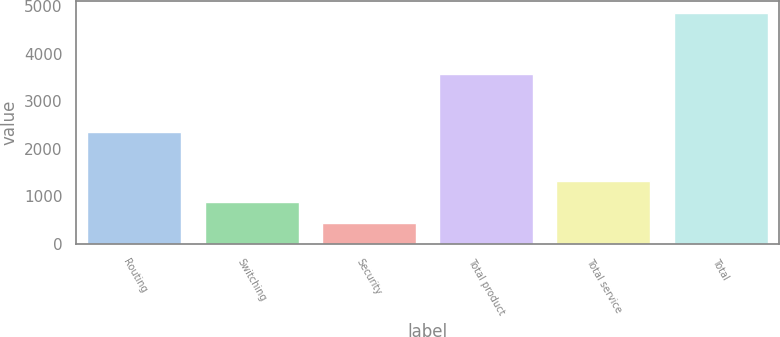Convert chart to OTSL. <chart><loc_0><loc_0><loc_500><loc_500><bar_chart><fcel>Routing<fcel>Switching<fcel>Security<fcel>Total product<fcel>Total service<fcel>Total<nl><fcel>2359.2<fcel>877.82<fcel>435.6<fcel>3563.1<fcel>1320.04<fcel>4857.8<nl></chart> 